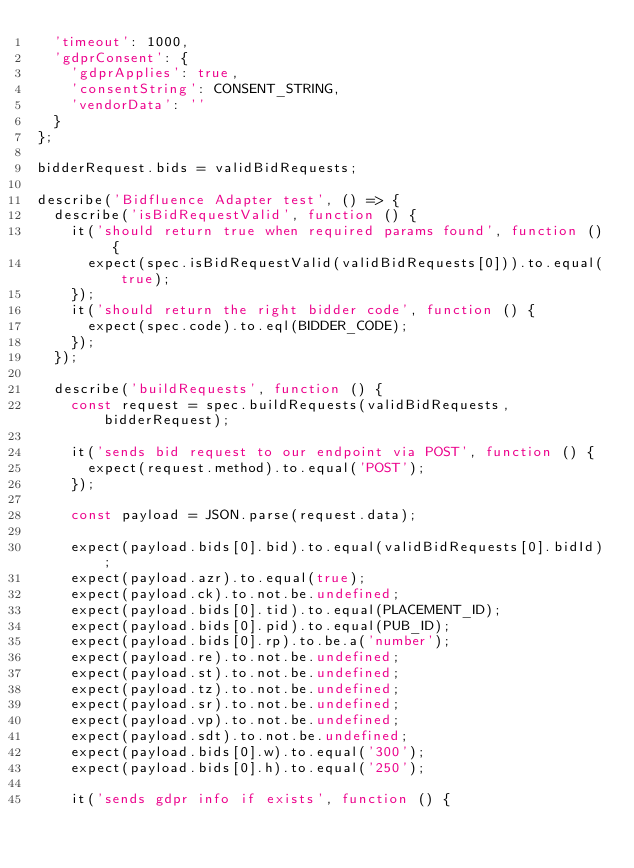Convert code to text. <code><loc_0><loc_0><loc_500><loc_500><_JavaScript_>  'timeout': 1000,
  'gdprConsent': {
    'gdprApplies': true,
    'consentString': CONSENT_STRING,
    'vendorData': ''
  }
};

bidderRequest.bids = validBidRequests;

describe('Bidfluence Adapter test', () => {
  describe('isBidRequestValid', function () {
    it('should return true when required params found', function () {
      expect(spec.isBidRequestValid(validBidRequests[0])).to.equal(true);
    });
    it('should return the right bidder code', function () {
      expect(spec.code).to.eql(BIDDER_CODE);
    });
  });

  describe('buildRequests', function () {
    const request = spec.buildRequests(validBidRequests, bidderRequest);

    it('sends bid request to our endpoint via POST', function () {
      expect(request.method).to.equal('POST');
    });

    const payload = JSON.parse(request.data);

    expect(payload.bids[0].bid).to.equal(validBidRequests[0].bidId);
    expect(payload.azr).to.equal(true);
    expect(payload.ck).to.not.be.undefined;
    expect(payload.bids[0].tid).to.equal(PLACEMENT_ID);
    expect(payload.bids[0].pid).to.equal(PUB_ID);
    expect(payload.bids[0].rp).to.be.a('number');
    expect(payload.re).to.not.be.undefined;
    expect(payload.st).to.not.be.undefined;
    expect(payload.tz).to.not.be.undefined;
    expect(payload.sr).to.not.be.undefined;
    expect(payload.vp).to.not.be.undefined;
    expect(payload.sdt).to.not.be.undefined;
    expect(payload.bids[0].w).to.equal('300');
    expect(payload.bids[0].h).to.equal('250');

    it('sends gdpr info if exists', function () {</code> 